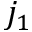Convert formula to latex. <formula><loc_0><loc_0><loc_500><loc_500>j _ { 1 }</formula> 